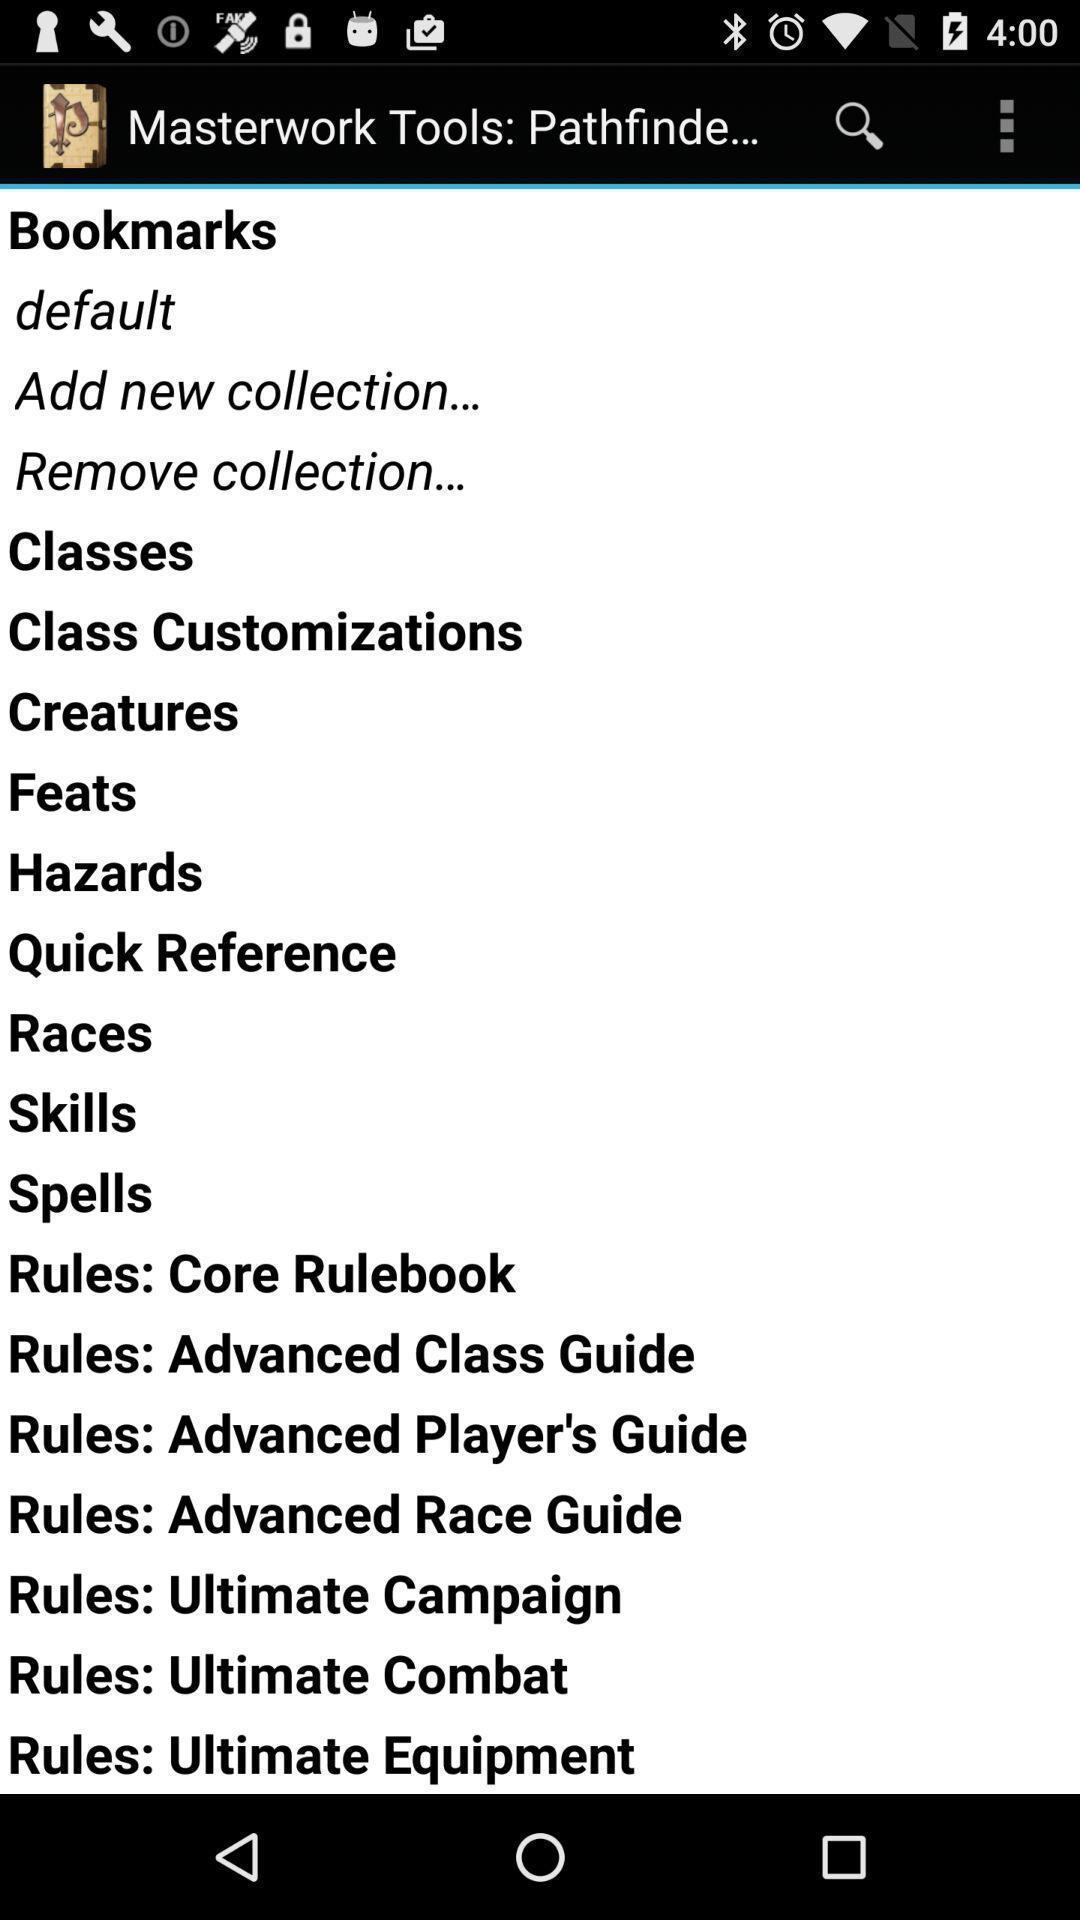Provide a detailed account of this screenshot. Page displaying the list of masterwork tools. 